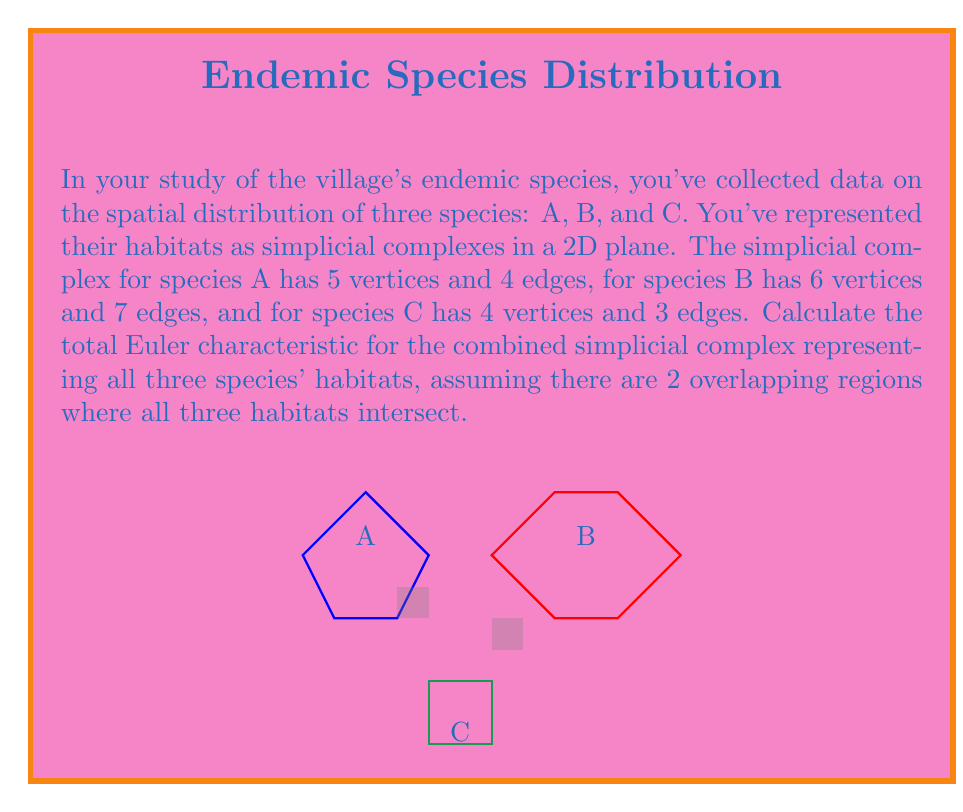Can you answer this question? To solve this problem, we need to use the Euler characteristic formula and consider the overlapping regions. Let's break it down step-by-step:

1) The Euler characteristic (χ) for a 2D simplicial complex is given by:
   $$χ = V - E + F$$
   where V is the number of vertices, E is the number of edges, and F is the number of faces.

2) For each species:
   Species A: $χ_A = 5 - 4 = 1$ (no faces)
   Species B: $χ_B = 6 - 7 = -1$ (no faces)
   Species C: $χ_C = 4 - 3 = 1$ (no faces)

3) If we simply add these up, we get: $χ_A + χ_B + χ_C = 1 + (-1) + 1 = 1$

4) However, we need to account for the overlapping regions. Each overlapping region adds a face to our complex, which increases the Euler characteristic by 1 for each region.

5) We're told there are 2 overlapping regions where all three habitats intersect. So we need to add 2 to our total:
   $$χ_{total} = χ_A + χ_B + χ_C + 2$$

6) Substituting the values:
   $$χ_{total} = 1 + (-1) + 1 + 2 = 3$$

Therefore, the total Euler characteristic for the combined simplicial complex is 3.
Answer: 3 